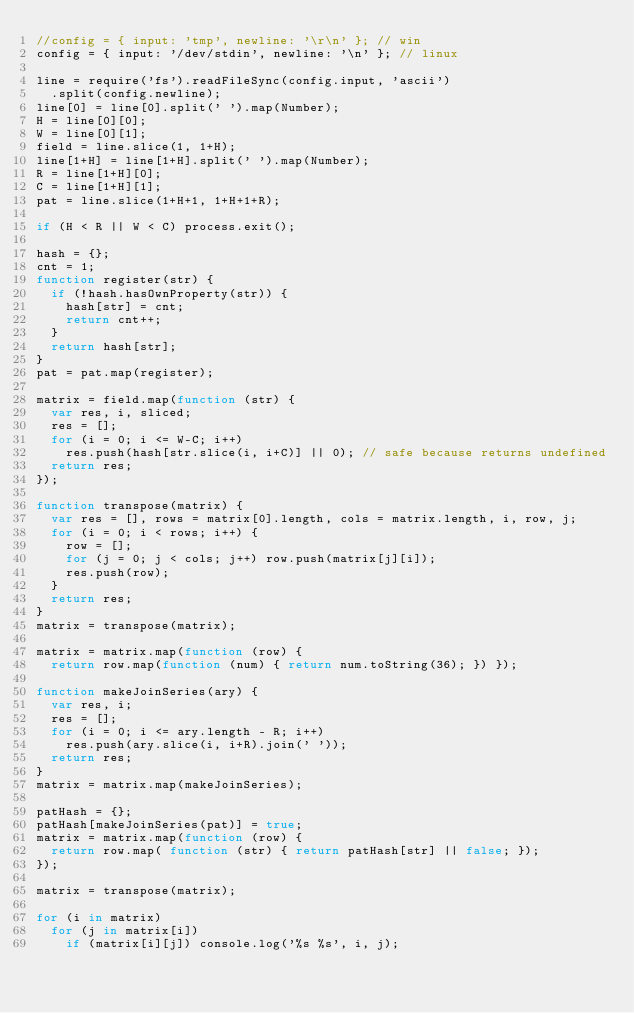<code> <loc_0><loc_0><loc_500><loc_500><_JavaScript_>//config = { input: 'tmp', newline: '\r\n' }; // win
config = { input: '/dev/stdin', newline: '\n' }; // linux
 
line = require('fs').readFileSync(config.input, 'ascii')
  .split(config.newline);
line[0] = line[0].split(' ').map(Number);
H = line[0][0];
W = line[0][1];
field = line.slice(1, 1+H);
line[1+H] = line[1+H].split(' ').map(Number);
R = line[1+H][0];
C = line[1+H][1];
pat = line.slice(1+H+1, 1+H+1+R);
 
if (H < R || W < C) process.exit();
 
hash = {};
cnt = 1;
function register(str) {
  if (!hash.hasOwnProperty(str)) {
    hash[str] = cnt;
    return cnt++;
  }
  return hash[str];
}
pat = pat.map(register);
 
matrix = field.map(function (str) {
  var res, i, sliced;
  res = [];
  for (i = 0; i <= W-C; i++)
    res.push(hash[str.slice(i, i+C)] || 0); // safe because returns undefined
  return res;
});

function transpose(matrix) {
  var res = [], rows = matrix[0].length, cols = matrix.length, i, row, j;
  for (i = 0; i < rows; i++) {
    row = [];
    for (j = 0; j < cols; j++) row.push(matrix[j][i]);
    res.push(row);
  }
  return res;
}
matrix = transpose(matrix);

matrix = matrix.map(function (row) {
  return row.map(function (num) { return num.toString(36); }) });

function makeJoinSeries(ary) {
  var res, i;
  res = [];
  for (i = 0; i <= ary.length - R; i++)
    res.push(ary.slice(i, i+R).join(' '));
  return res;
}
matrix = matrix.map(makeJoinSeries);

patHash = {};
patHash[makeJoinSeries(pat)] = true;
matrix = matrix.map(function (row) {
  return row.map( function (str) { return patHash[str] || false; });
});

matrix = transpose(matrix);

for (i in matrix)
  for (j in matrix[i])
    if (matrix[i][j]) console.log('%s %s', i, j);</code> 